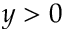<formula> <loc_0><loc_0><loc_500><loc_500>y > 0</formula> 